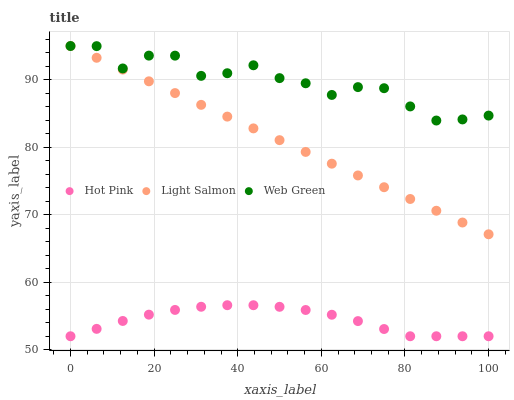Does Hot Pink have the minimum area under the curve?
Answer yes or no. Yes. Does Web Green have the maximum area under the curve?
Answer yes or no. Yes. Does Web Green have the minimum area under the curve?
Answer yes or no. No. Does Hot Pink have the maximum area under the curve?
Answer yes or no. No. Is Light Salmon the smoothest?
Answer yes or no. Yes. Is Web Green the roughest?
Answer yes or no. Yes. Is Hot Pink the smoothest?
Answer yes or no. No. Is Hot Pink the roughest?
Answer yes or no. No. Does Hot Pink have the lowest value?
Answer yes or no. Yes. Does Web Green have the lowest value?
Answer yes or no. No. Does Web Green have the highest value?
Answer yes or no. Yes. Does Hot Pink have the highest value?
Answer yes or no. No. Is Hot Pink less than Light Salmon?
Answer yes or no. Yes. Is Light Salmon greater than Hot Pink?
Answer yes or no. Yes. Does Web Green intersect Light Salmon?
Answer yes or no. Yes. Is Web Green less than Light Salmon?
Answer yes or no. No. Is Web Green greater than Light Salmon?
Answer yes or no. No. Does Hot Pink intersect Light Salmon?
Answer yes or no. No. 